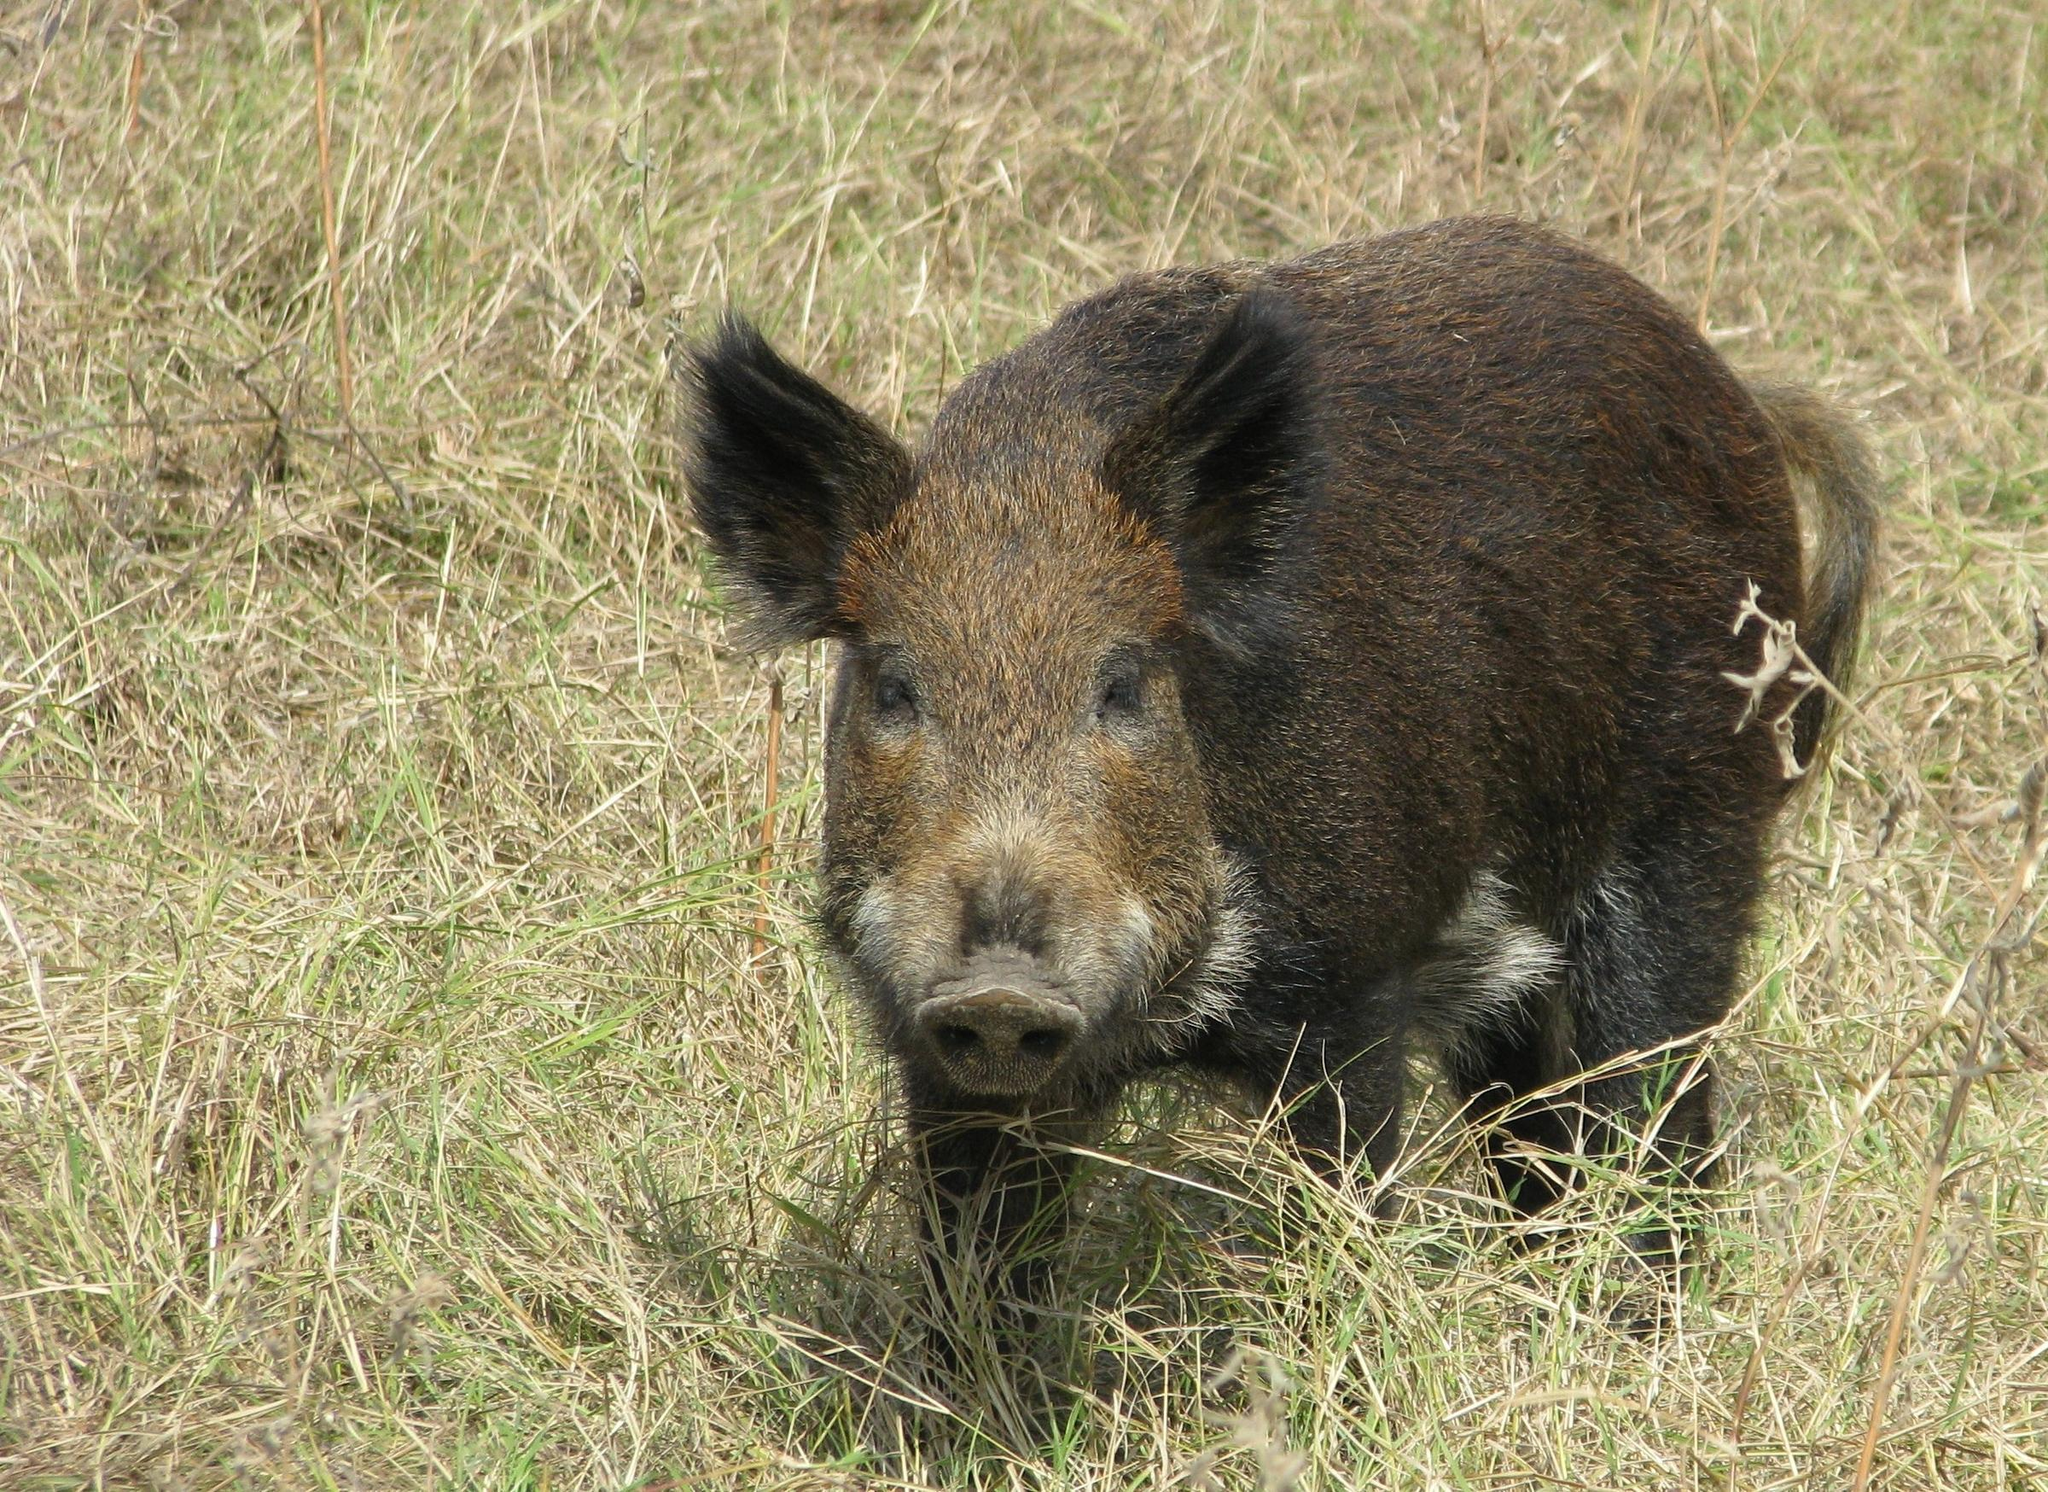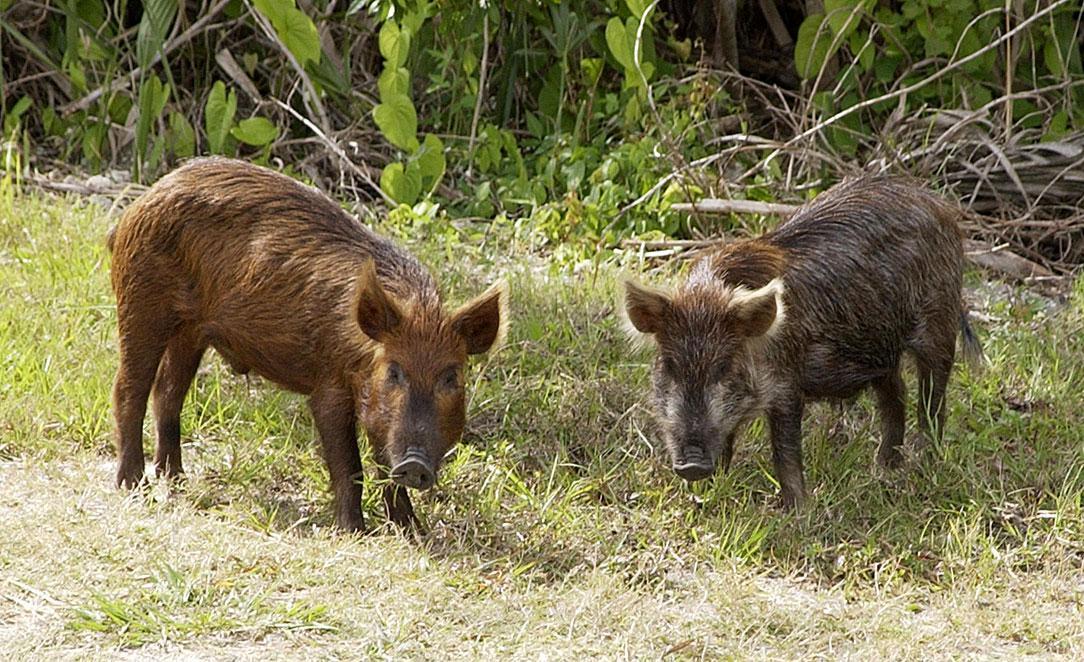The first image is the image on the left, the second image is the image on the right. Considering the images on both sides, is "There are at most two wild boars" valid? Answer yes or no. No. 